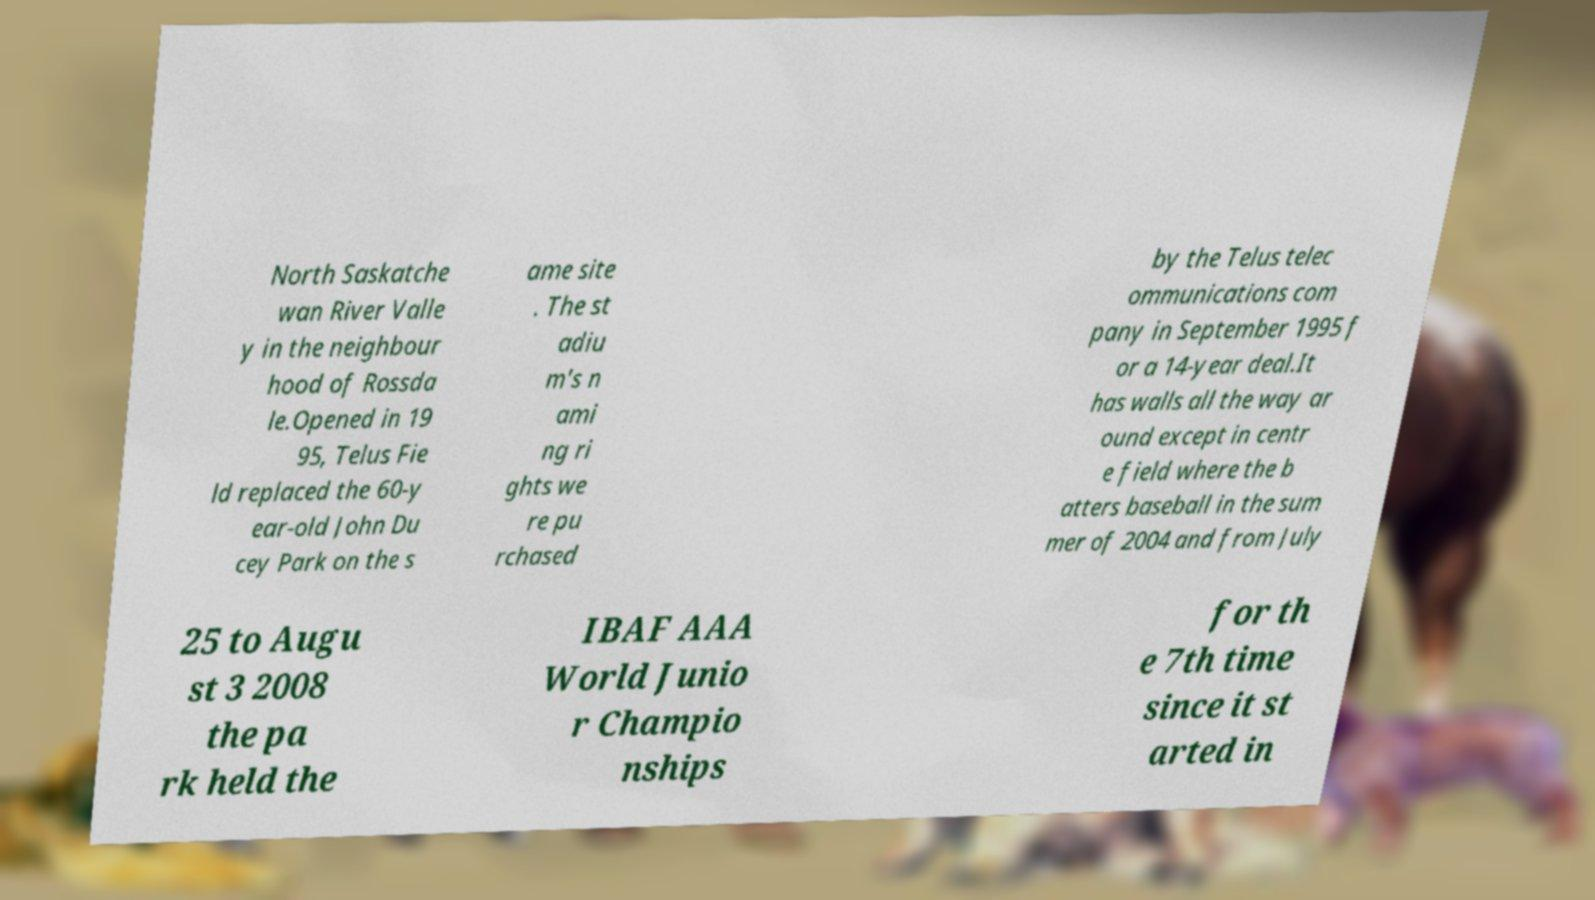Please identify and transcribe the text found in this image. North Saskatche wan River Valle y in the neighbour hood of Rossda le.Opened in 19 95, Telus Fie ld replaced the 60-y ear-old John Du cey Park on the s ame site . The st adiu m's n ami ng ri ghts we re pu rchased by the Telus telec ommunications com pany in September 1995 f or a 14-year deal.It has walls all the way ar ound except in centr e field where the b atters baseball in the sum mer of 2004 and from July 25 to Augu st 3 2008 the pa rk held the IBAF AAA World Junio r Champio nships for th e 7th time since it st arted in 